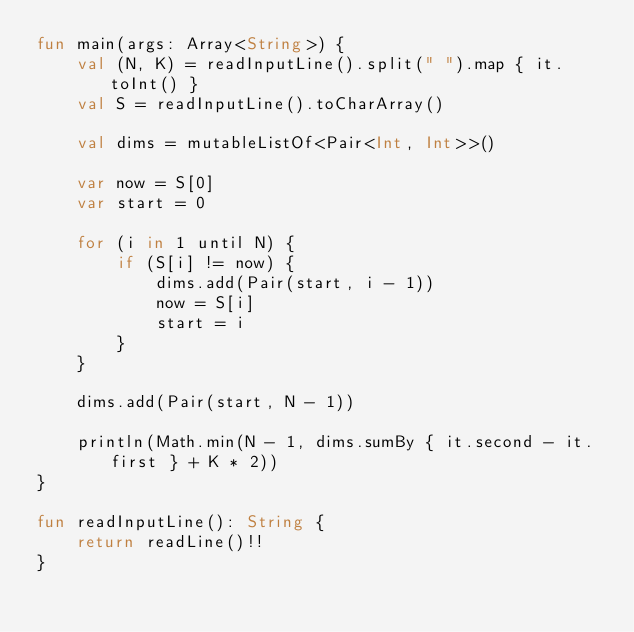<code> <loc_0><loc_0><loc_500><loc_500><_Kotlin_>fun main(args: Array<String>) {
    val (N, K) = readInputLine().split(" ").map { it.toInt() }
    val S = readInputLine().toCharArray()

    val dims = mutableListOf<Pair<Int, Int>>()
    
    var now = S[0]
    var start = 0
    
    for (i in 1 until N) {
        if (S[i] != now) {
            dims.add(Pair(start, i - 1))
            now = S[i]
            start = i
        }
    }

    dims.add(Pair(start, N - 1))

    println(Math.min(N - 1, dims.sumBy { it.second - it.first } + K * 2))
}

fun readInputLine(): String {
    return readLine()!!
}
</code> 